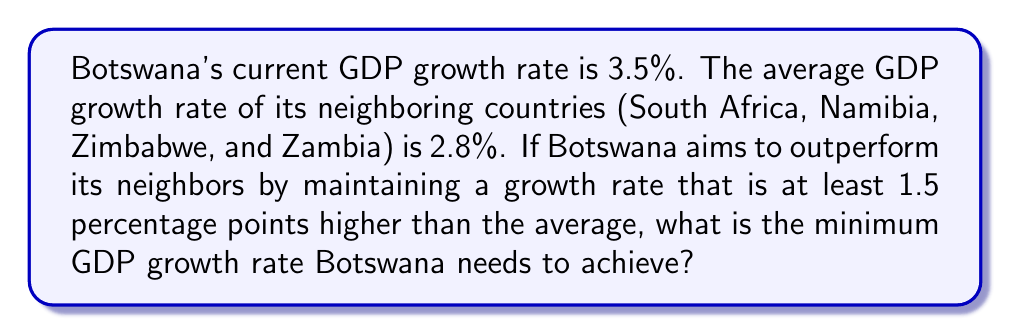Can you answer this question? To solve this problem, we need to follow these steps:

1. Identify the given information:
   - Botswana's current GDP growth rate: 3.5%
   - Average GDP growth rate of neighboring countries: 2.8%
   - Desired outperformance: 1.5 percentage points higher

2. Calculate the minimum GDP growth rate for Botswana:
   Let $x$ be the minimum GDP growth rate Botswana needs to achieve.
   
   We can express this as an inequality:
   $$x \geq 2.8\% + 1.5\%$$

3. Solve the inequality:
   $$x \geq 4.3\%$$

4. Compare with Botswana's current growth rate:
   Since 4.3% > 3.5%, Botswana needs to increase its GDP growth rate to meet the target.

Therefore, the minimum GDP growth rate Botswana needs to achieve to outperform its neighboring countries by at least 1.5 percentage points is 4.3%.
Answer: 4.3% 